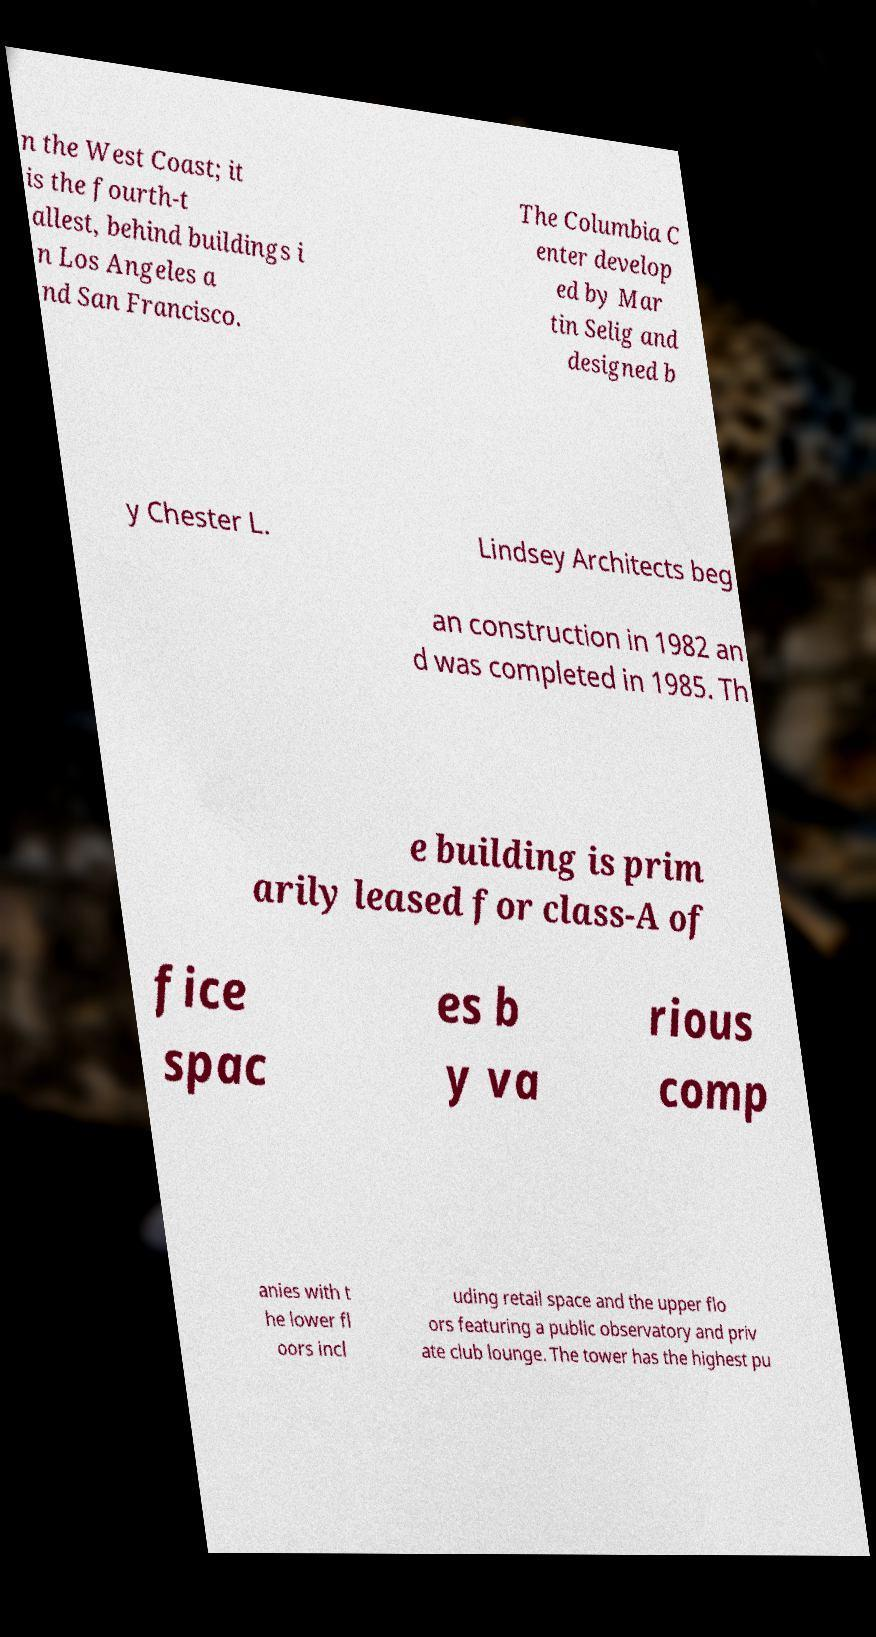Could you extract and type out the text from this image? n the West Coast; it is the fourth-t allest, behind buildings i n Los Angeles a nd San Francisco. The Columbia C enter develop ed by Mar tin Selig and designed b y Chester L. Lindsey Architects beg an construction in 1982 an d was completed in 1985. Th e building is prim arily leased for class-A of fice spac es b y va rious comp anies with t he lower fl oors incl uding retail space and the upper flo ors featuring a public observatory and priv ate club lounge. The tower has the highest pu 